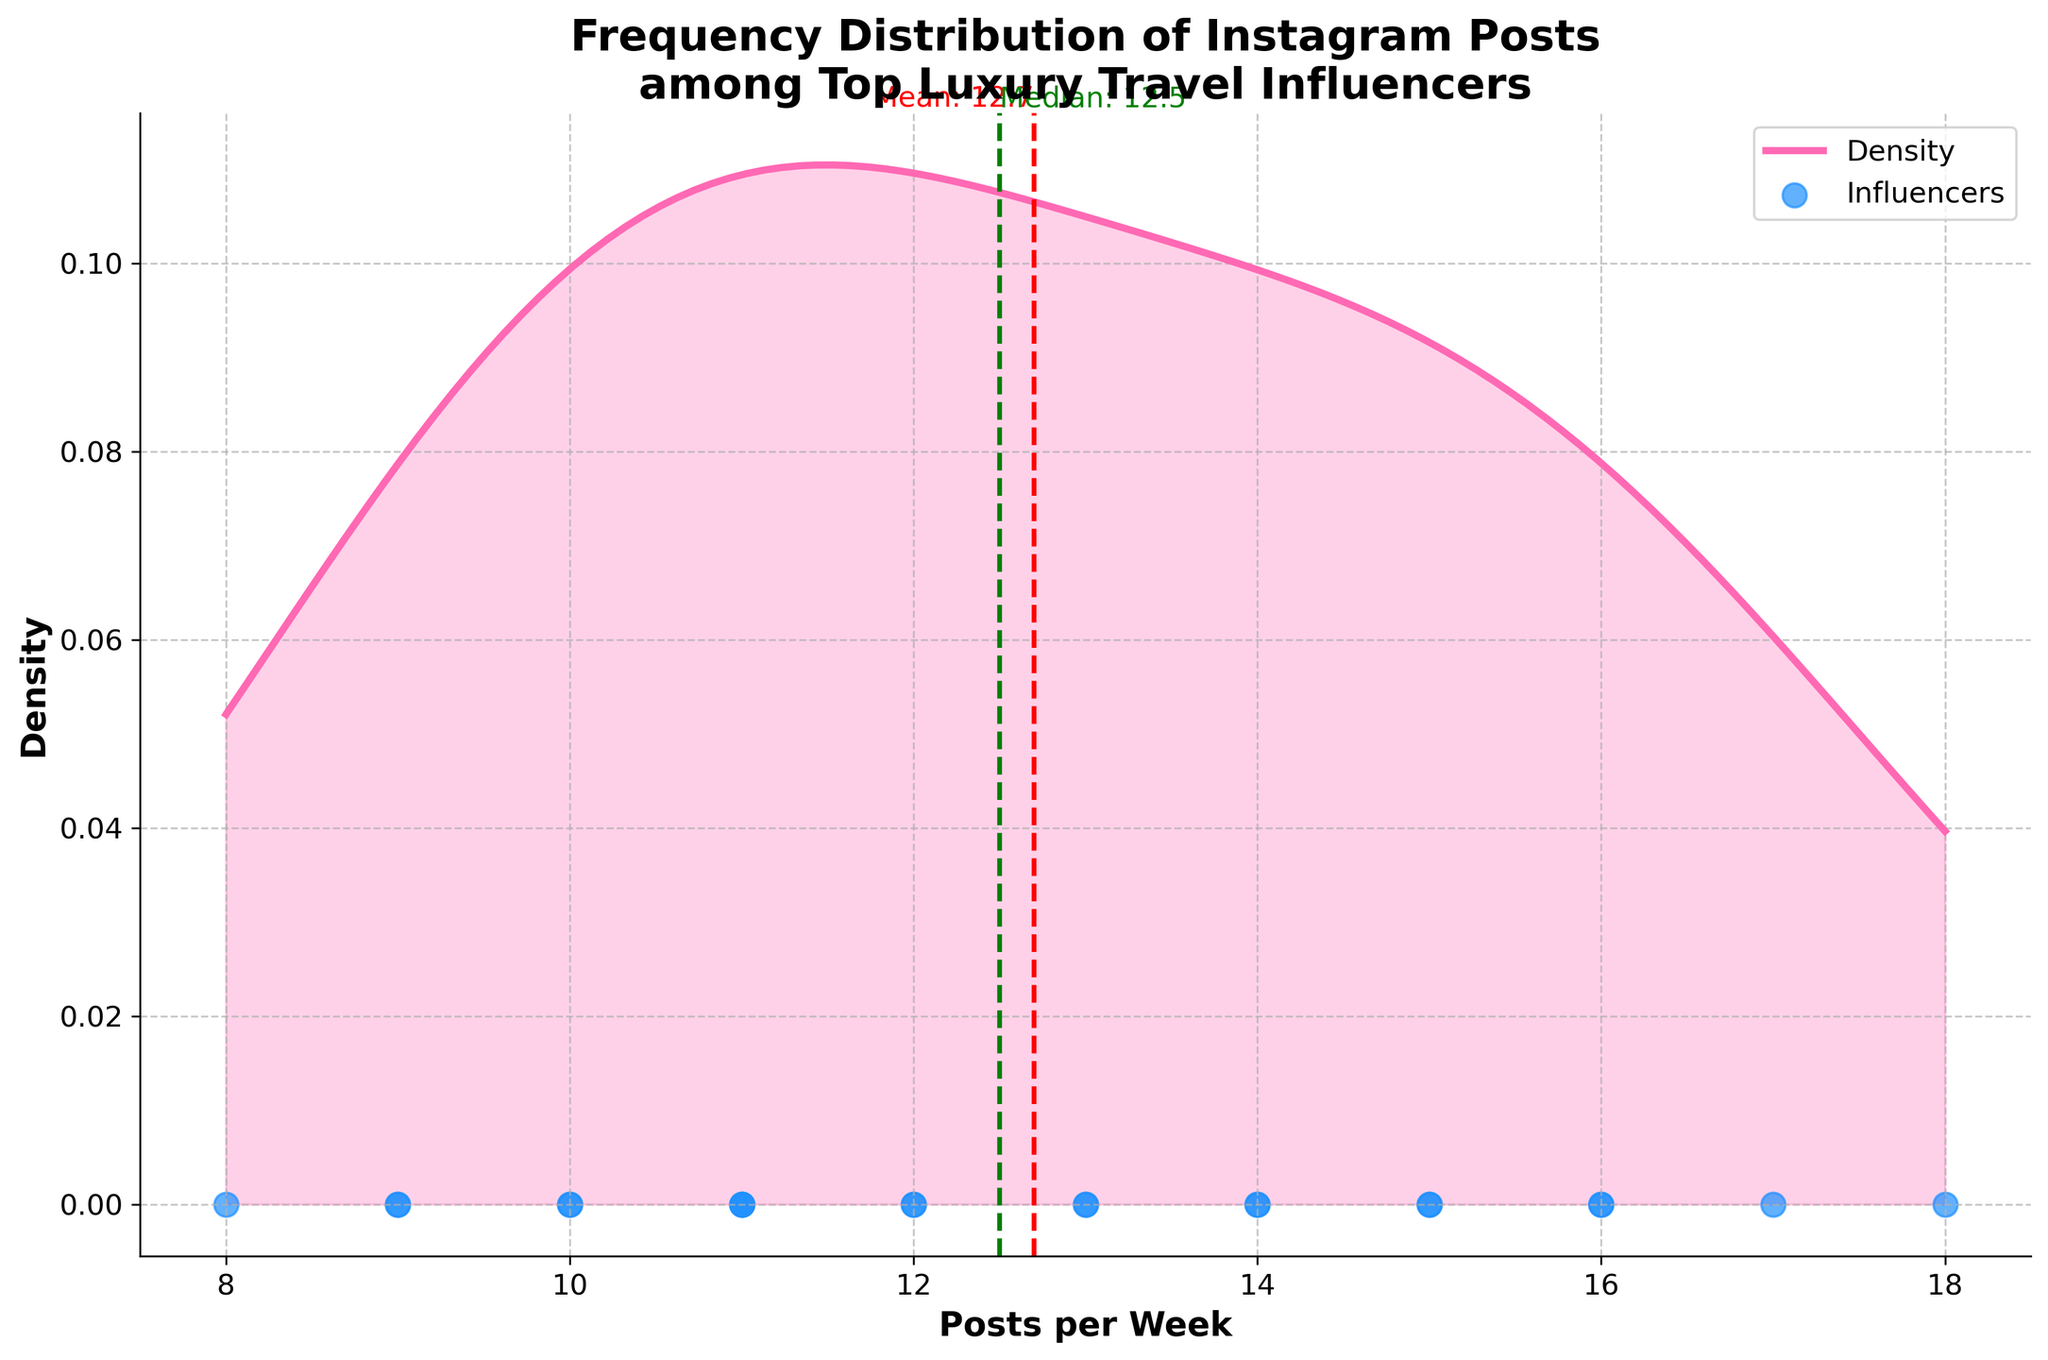What's the title of the plot? The title of the plot is located at the top center of the figure. It reads, "Frequency Distribution of Instagram Posts among Top Luxury Travel Influencers".
Answer: Frequency Distribution of Instagram Posts among Top Luxury Travel Influencers How many influencers are represented in the scatter plot? The scatter plot shows individual data points where each represents an influencer. By counting these points, we see there are 20 influencers.
Answer: 20 What does the color red dashed vertical line represent? The red dashed vertical line is labeled and represents the mean value of the number of posts per week, as indicated by the text annotation next to it.
Answer: The mean value What's the average number of posts per week among these influencers? The red dashed vertical line is the mean, and the text annotation beside it states the average number of posts per week.
Answer: 12.85 Which influencer has the highest number of posts per week, and how many? By viewing the scatter plot, we identify the highest data point. Referring to the data, "LuxuryTravelInfluencer" has the highest number, with 18 posts per week.
Answer: LuxuryTravelInfluencer, 18 Is the median number of posts per week higher or lower than the average? The green dashed vertical line represents the median, and we compare its position to the red dashed vertical line representing the mean. The median line is at a slightly lower value than the mean line.
Answer: Lower How does the distribution of posts per week visually appear? The density curve's shape and the fill indicate how posts per week are distributed. It appears to be roughly symmetric with a peak around the average number of posts, indicating a normal distribution.
Answer: Roughly symmetric What is the median number of posts per week among these influencers? The green dashed line is the median, with the text annotation indicating its exact value. The median number of posts per week is approximately 12.
Answer: 12 Which side of the mean value has a higher density of posts per week? Observing the density curve, it is higher on the left side of the mean than on the right, indicating more influencers post fewer times per week than the mean.
Answer: The left side Are there more influencers posting more or fewer times per week than the median? By checking the configuration of the scatter plot against the green median line, there are slightly more data points (influencers) on the left side of the median.
Answer: Fewer times per week 